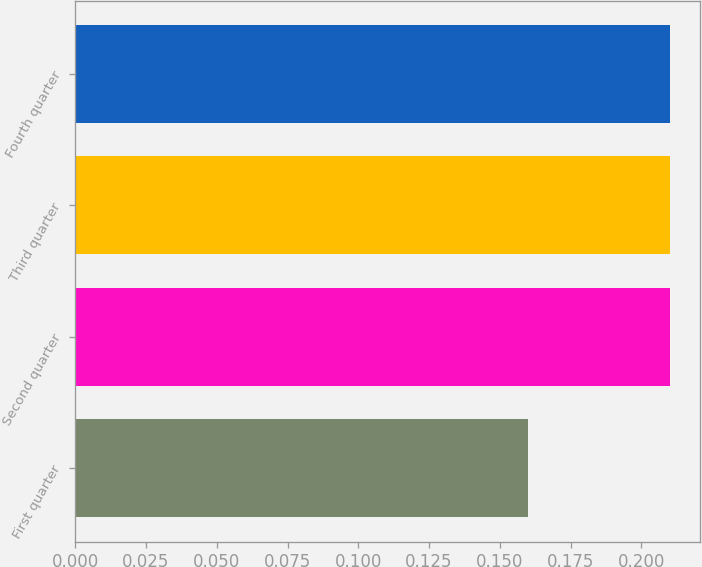Convert chart to OTSL. <chart><loc_0><loc_0><loc_500><loc_500><bar_chart><fcel>First quarter<fcel>Second quarter<fcel>Third quarter<fcel>Fourth quarter<nl><fcel>0.16<fcel>0.21<fcel>0.21<fcel>0.21<nl></chart> 